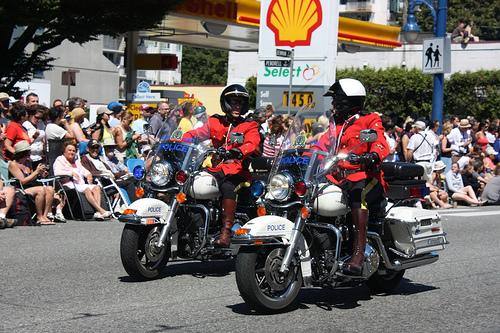What do the people seated by the road await?

Choices:
A) racing
B) nothing
C) parade
D) arrest parade 